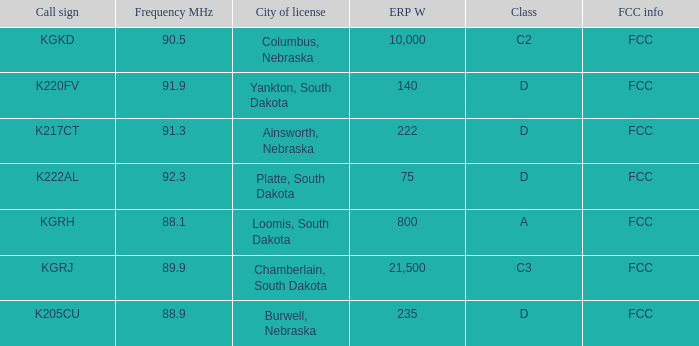What is the highest erp w with a 90.5 frequency mhz? 10000.0. 